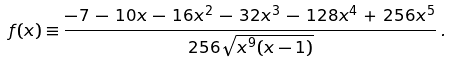<formula> <loc_0><loc_0><loc_500><loc_500>f ( x ) \equiv \frac { - 7 \, - \, 1 0 x \, - \, 1 6 x ^ { 2 } \, - \, 3 2 x ^ { 3 } \, - \, 1 2 8 x ^ { 4 } \, + \, 2 5 6 x ^ { 5 } } { 2 5 6 \sqrt { x ^ { 9 } ( x - 1 ) } } \, .</formula> 